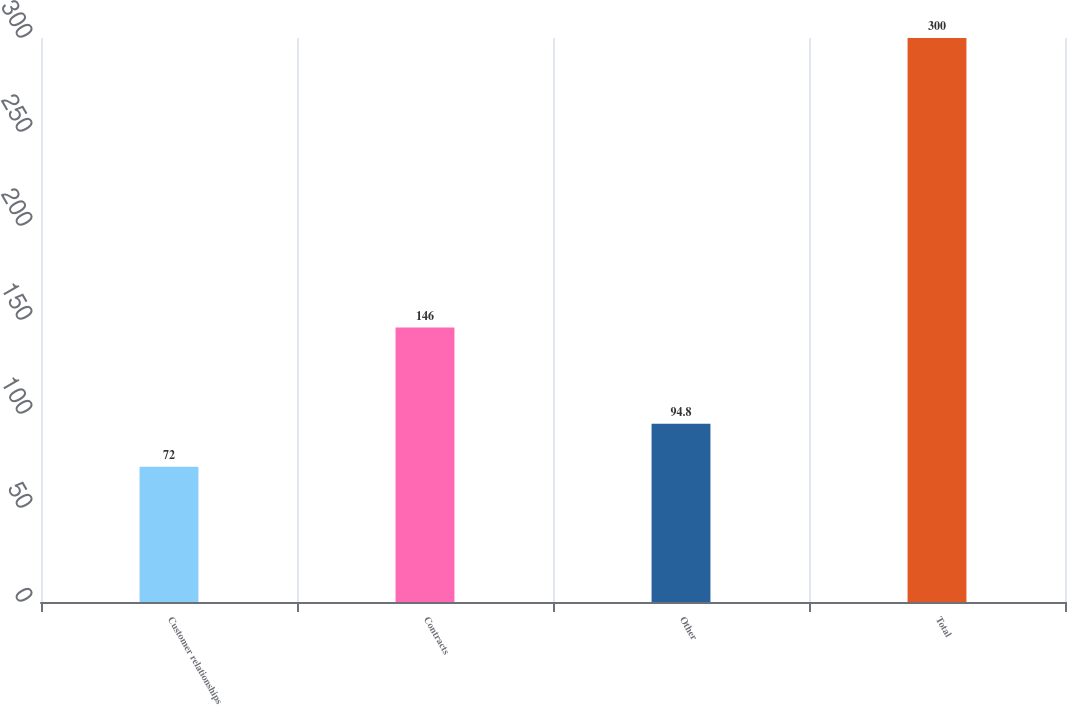<chart> <loc_0><loc_0><loc_500><loc_500><bar_chart><fcel>Customer relationships<fcel>Contracts<fcel>Other<fcel>Total<nl><fcel>72<fcel>146<fcel>94.8<fcel>300<nl></chart> 